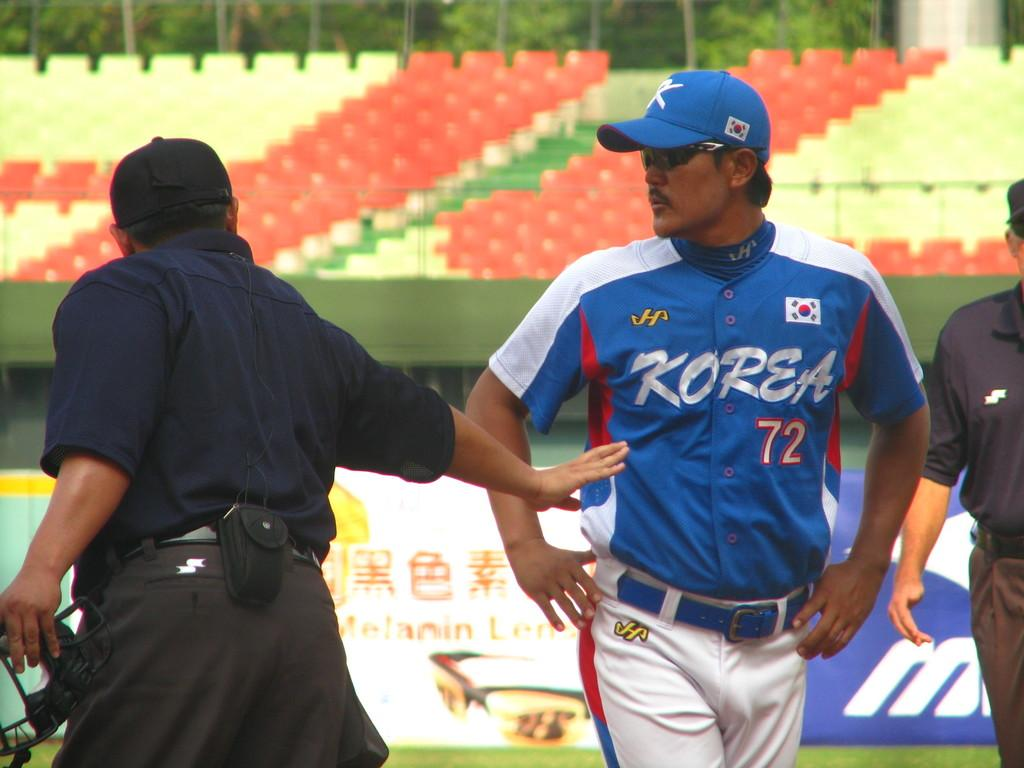How many people are present in the image? There are three people standing in the image. What type of advertisement or display is the image likely to be? The image appears to be a hoarding. What color chairs can be seen in the image? There are yellow and red chairs in the image. What can be seen in the background of the image? There are trees visible in the background of the image. What type of joke is being told by the people in the image? There is no indication of a joke being told in the image; it simply shows three people standing. 